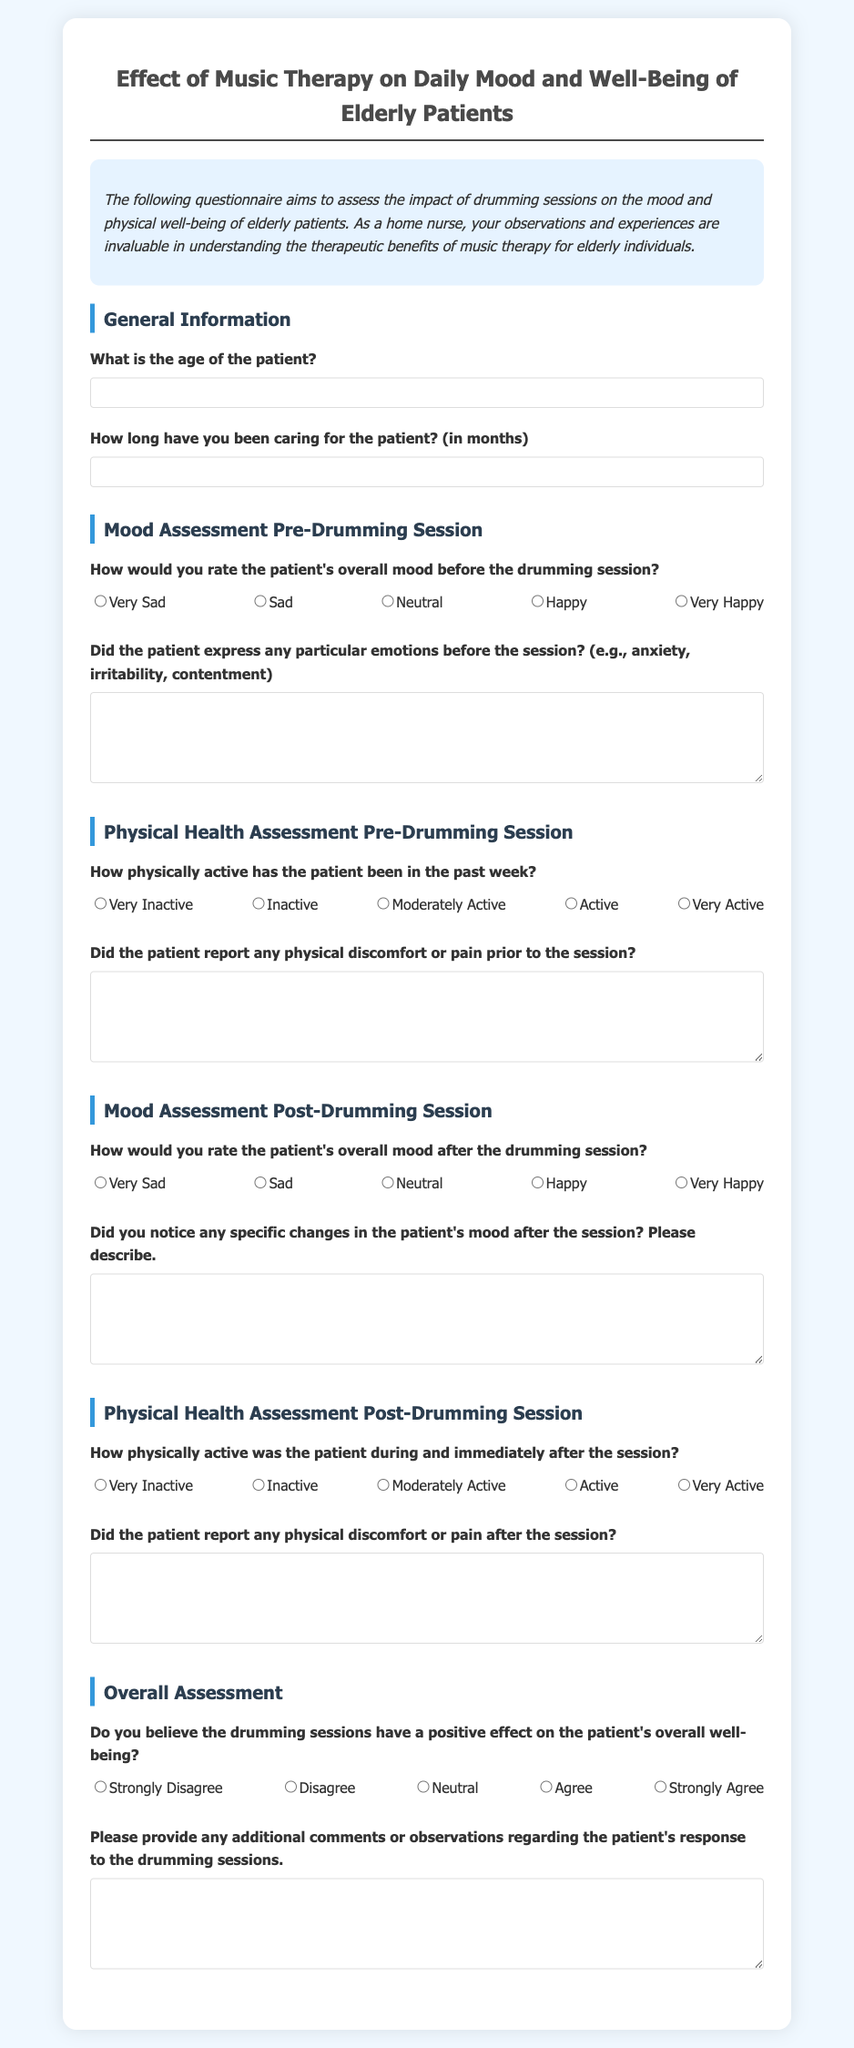What is the purpose of the questionnaire? The purpose of the questionnaire is to assess the impact of drumming sessions on the mood and physical well-being of elderly patients.
Answer: Assess the impact of drumming sessions on mood and well-being What is the first section in the questionnaire? The first section of the questionnaire is titled "General Information."
Answer: General Information What scale is used to rate the patient's overall mood? The questionnaire uses a Likert scale ranging from "Very Sad" to "Very Happy" to rate the patient's overall mood.
Answer: Likert scale What question is asked regarding physical discomfort before the session? The questionnaire asks, "Did the patient report any physical discomfort or pain prior to the session?"
Answer: Did the patient report any physical discomfort or pain prior to the session? What type of comments can be provided in the overall assessment section? Respondents can provide any additional comments or observations regarding the patient's response to the drumming sessions.
Answer: Additional comments or observations regarding the patient's response 